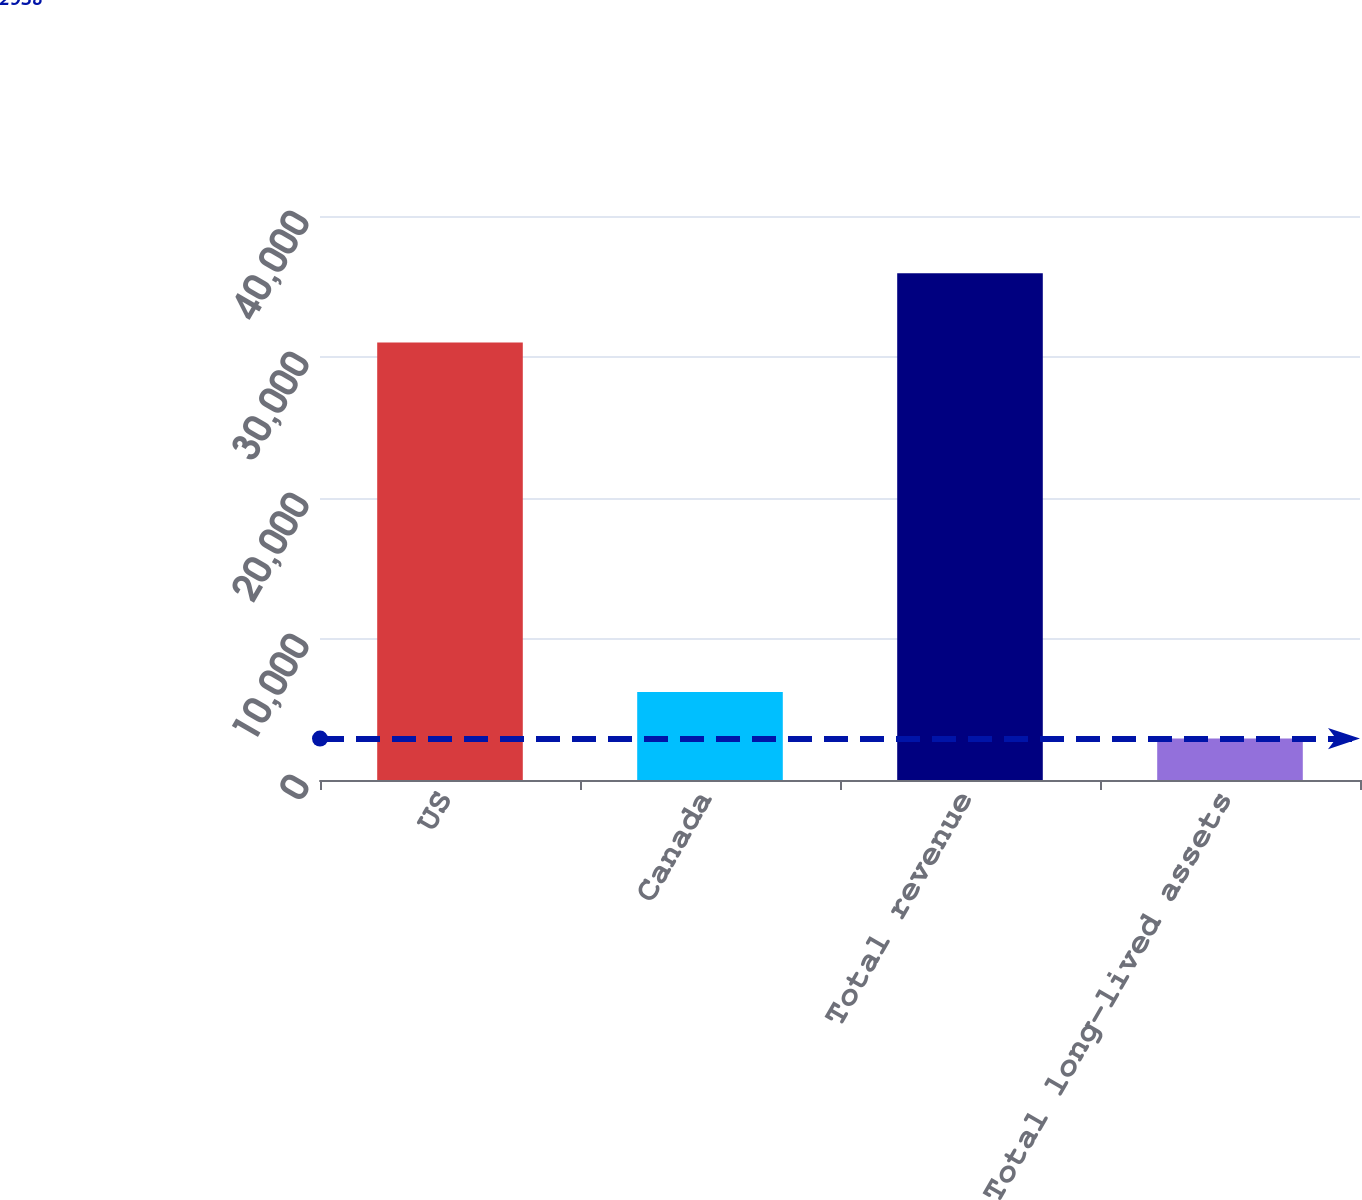Convert chart. <chart><loc_0><loc_0><loc_500><loc_500><bar_chart><fcel>US<fcel>Canada<fcel>Total revenue<fcel>Total long-lived assets<nl><fcel>31031<fcel>6237.6<fcel>35934<fcel>2938<nl></chart> 